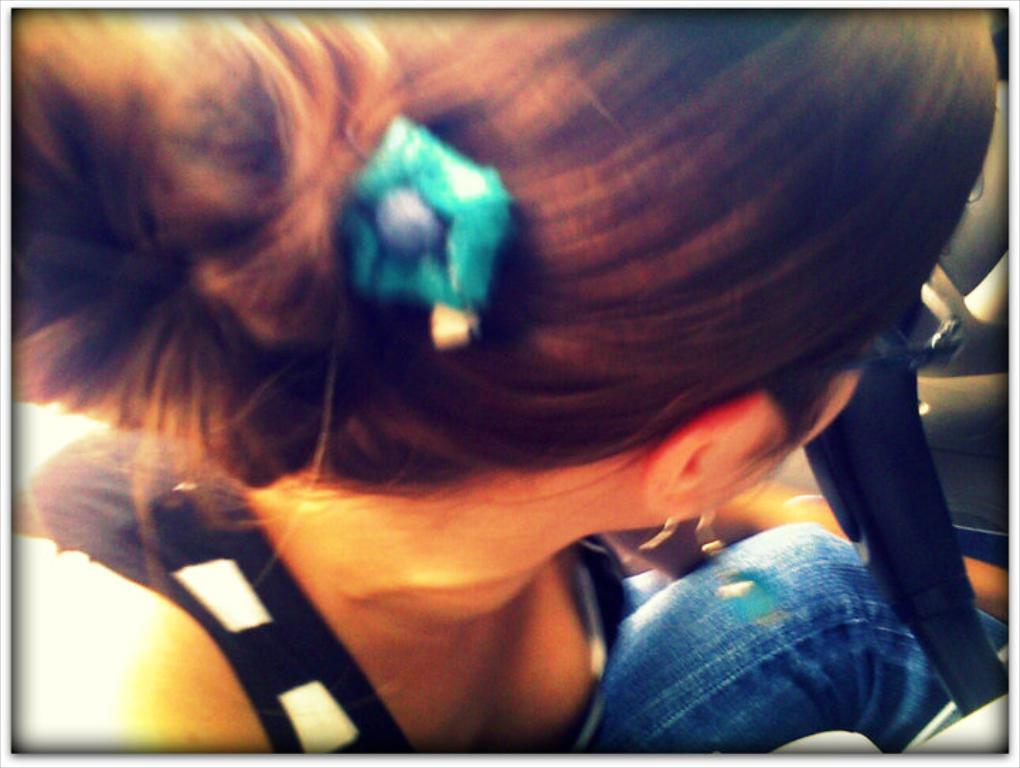What is the main subject of the image? The main subject of the image is a lady. What is the lady doing in the image? The lady is sitting in the image. What type of grip does the lady have on the clover in the image? There is no clover present in the image, and therefore no grip can be observed. How much honey is visible in the image? There is no honey present in the image. 